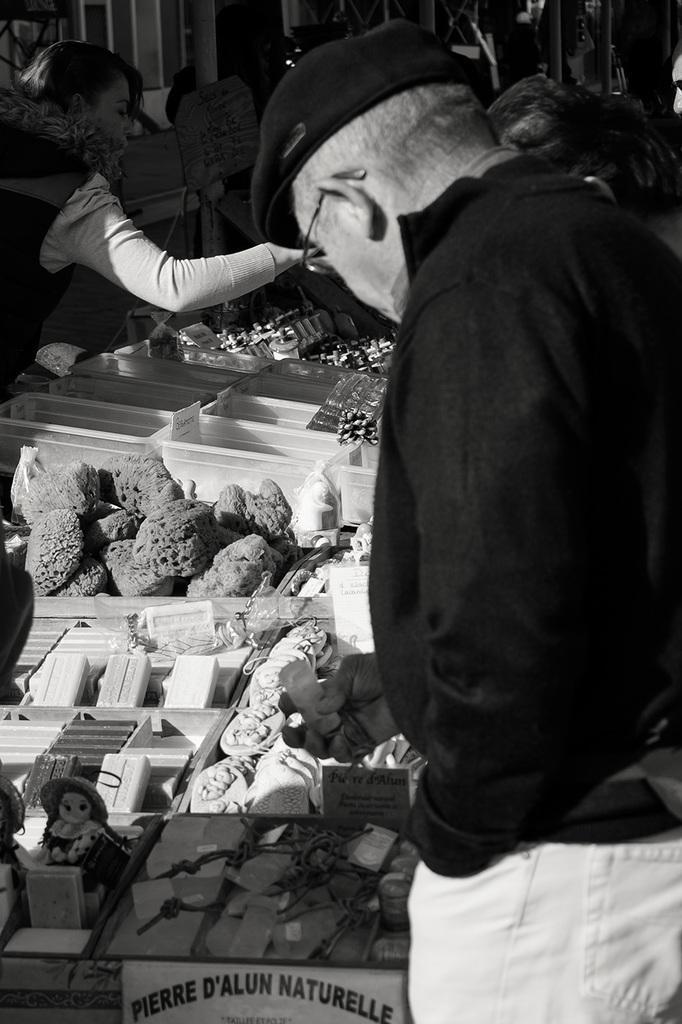In one or two sentences, can you explain what this image depicts? There are people. This is stall and we can see objects, boxes and dolls. 